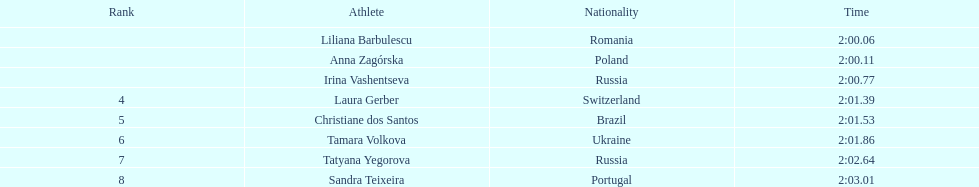What athletes are in the top five for the women's 800 metres? Liliana Barbulescu, Anna Zagórska, Irina Vashentseva, Laura Gerber, Christiane dos Santos. Which athletes are in the top 3? Liliana Barbulescu, Anna Zagórska, Irina Vashentseva. Who is the second place runner in the women's 800 metres? Anna Zagórska. What is the second place runner's time? 2:00.11. 